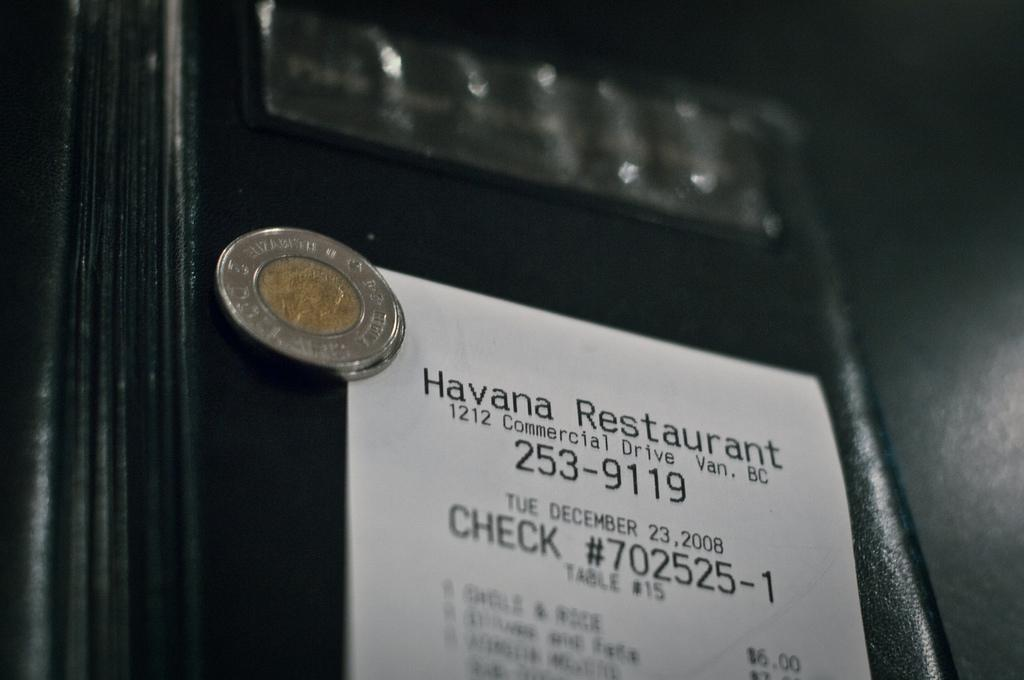<image>
Render a clear and concise summary of the photo. A coin sits on top of a receipt for the Havana restaurant. 